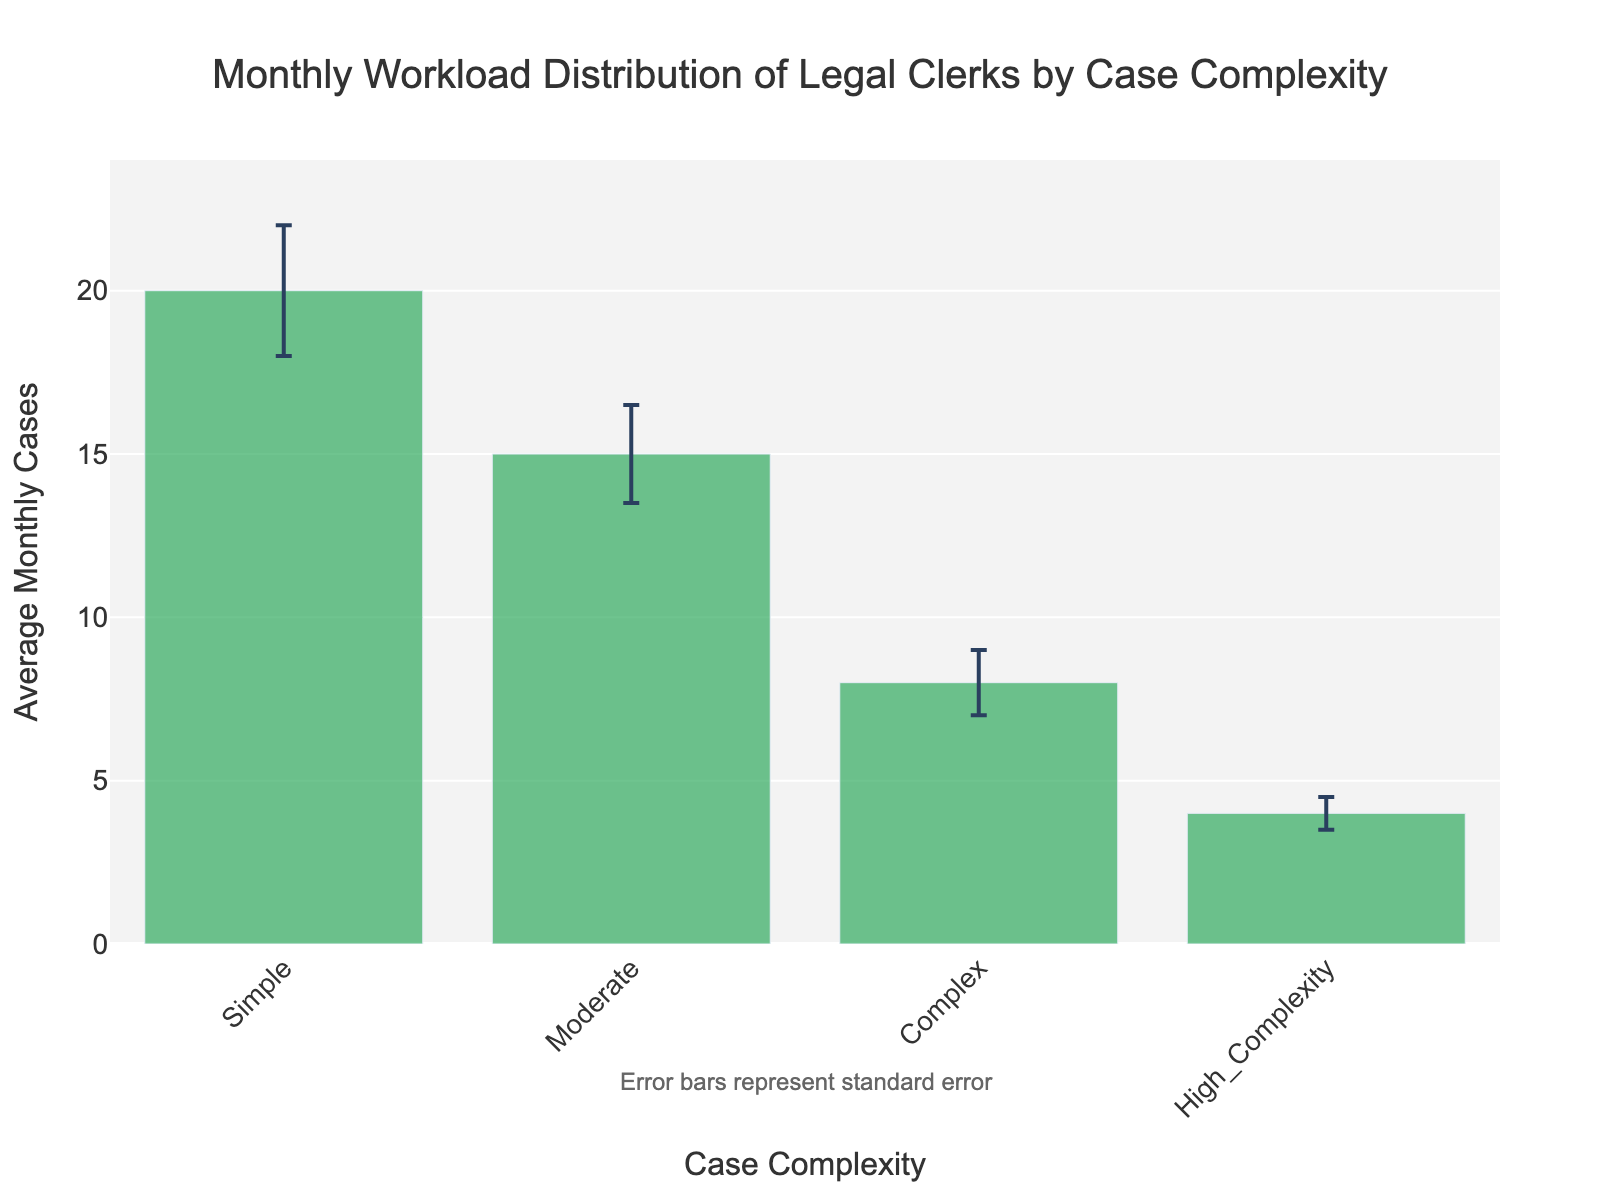What's the title of the chart? The title is typically positioned at the top of the chart and clearly indicates what the data is about: "Monthly Workload Distribution of Legal Clerks by Case Complexity"
Answer: Monthly Workload Distribution of Legal Clerks by Case Complexity How many categories of case complexity are shown? The categories of case complexity are represented on the x-axis of the bar chart. There are four distinct bars, each labeled with a different category.
Answer: Four Which category has the highest average monthly cases? By looking at the height of the bars, the bar with the tallest height represents the highest average monthly cases. The "Simple" category stands out as the tallest.
Answer: Simple What is the lowest average number of monthly cases and which category does it represent? The lowest bar in height indicates the lowest average number of monthly cases. The "High_Complexity" category has the shortest bar with an average of 4 monthly cases.
Answer: 4, High_Complexity What is the average number of monthly cases for the "Moderate" category? This value is displayed on top of the corresponding bar. The "Moderate" category shows an average of 15 monthly cases.
Answer: 15 What is the range of error for the "Complex" category? The error bars represent the standard error and give a range around the mean. For "Complex", the average number of cases is 8, with a standard error of 1, indicating a range of [8-1, 8+1].
Answer: [7, 9] How much higher is the average number of monthly cases for the "Simple" category compared to the "High_Complexity" category? The bar for "Simple" has an average of 20, while "High_Complexity" is 4. Subtract the two to find the difference: 20 - 4.
Answer: 16 Which category has the smallest error bar, and what does this imply? The "High_Complexity" category has the smallest error bar, indicating the standard error is the lowest at 0.5. This implies more consistency in the average monthly cases for this category.
Answer: High_Complexity What is the total average monthly workload for all categories combined? Add the average monthly cases for all categories: 20 (Simple) + 15 (Moderate) + 8 (Complex) + 4 (High_Complexity) = 47.
Answer: 47 What additional information is provided below the chart? There is an annotation below the chart stating, "Error bars represent standard error", indicating the precision of the average values shown.
Answer: Error bars represent standard error 